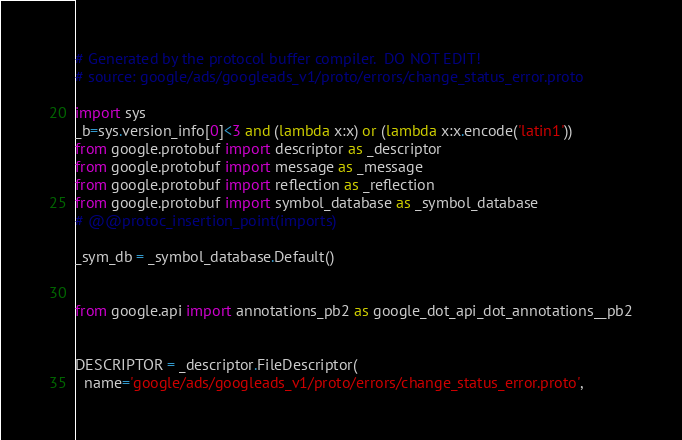Convert code to text. <code><loc_0><loc_0><loc_500><loc_500><_Python_># Generated by the protocol buffer compiler.  DO NOT EDIT!
# source: google/ads/googleads_v1/proto/errors/change_status_error.proto

import sys
_b=sys.version_info[0]<3 and (lambda x:x) or (lambda x:x.encode('latin1'))
from google.protobuf import descriptor as _descriptor
from google.protobuf import message as _message
from google.protobuf import reflection as _reflection
from google.protobuf import symbol_database as _symbol_database
# @@protoc_insertion_point(imports)

_sym_db = _symbol_database.Default()


from google.api import annotations_pb2 as google_dot_api_dot_annotations__pb2


DESCRIPTOR = _descriptor.FileDescriptor(
  name='google/ads/googleads_v1/proto/errors/change_status_error.proto',</code> 